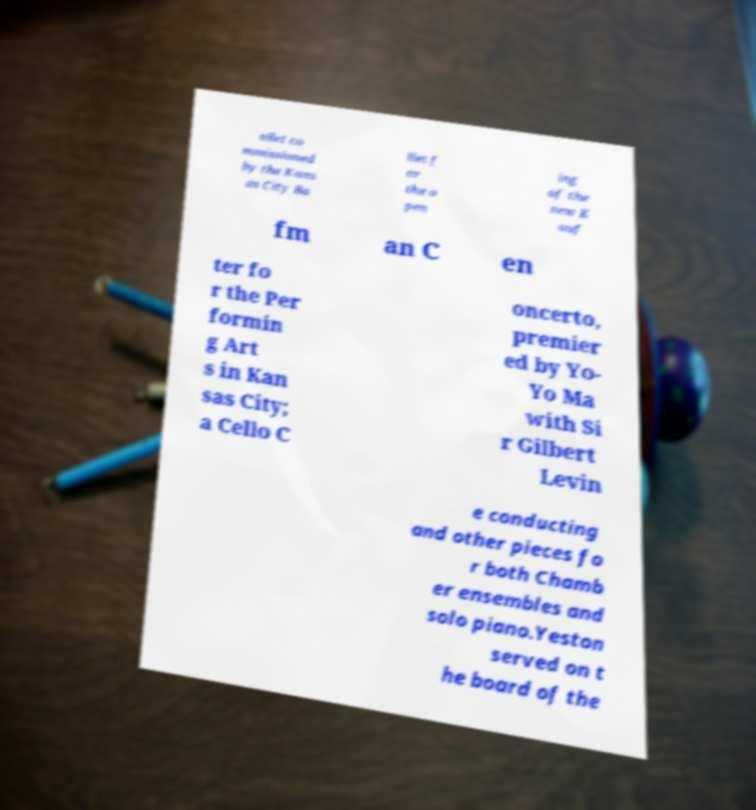For documentation purposes, I need the text within this image transcribed. Could you provide that? allet co mmissioned by the Kans as City Ba llet f or the o pen ing of the new K auf fm an C en ter fo r the Per formin g Art s in Kan sas City; a Cello C oncerto, premier ed by Yo- Yo Ma with Si r Gilbert Levin e conducting and other pieces fo r both Chamb er ensembles and solo piano.Yeston served on t he board of the 